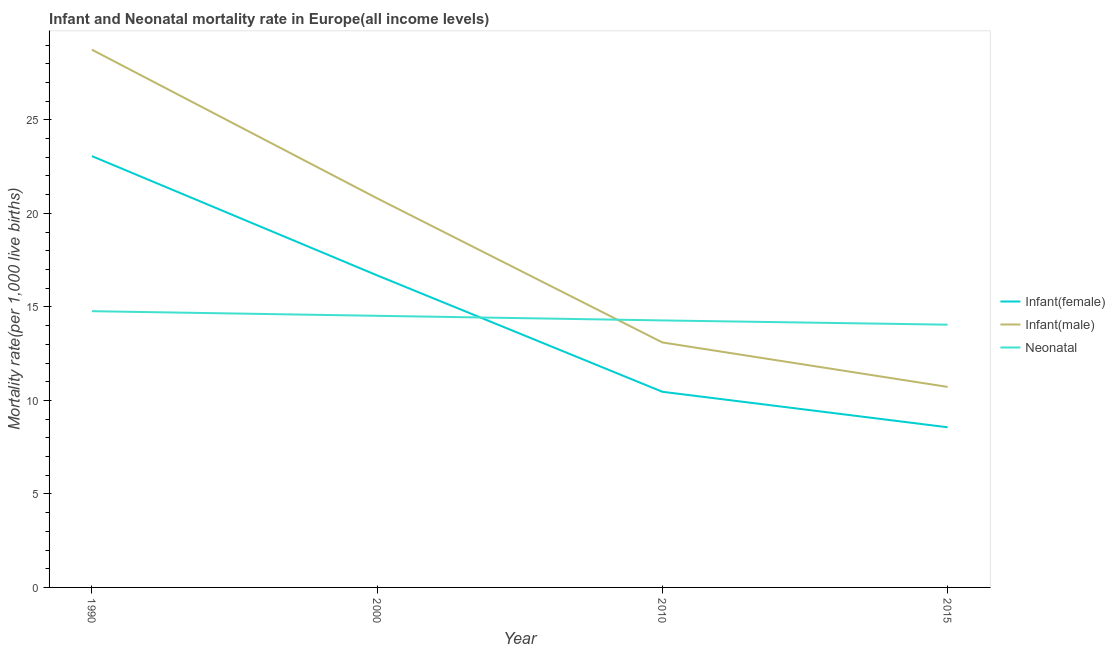How many different coloured lines are there?
Your answer should be compact. 3. Does the line corresponding to infant mortality rate(female) intersect with the line corresponding to neonatal mortality rate?
Your answer should be compact. Yes. What is the infant mortality rate(male) in 2015?
Provide a succinct answer. 10.72. Across all years, what is the maximum infant mortality rate(male)?
Your response must be concise. 28.75. Across all years, what is the minimum infant mortality rate(male)?
Your answer should be very brief. 10.72. In which year was the neonatal mortality rate minimum?
Make the answer very short. 2015. What is the total neonatal mortality rate in the graph?
Provide a succinct answer. 57.62. What is the difference between the neonatal mortality rate in 2010 and that in 2015?
Ensure brevity in your answer.  0.23. What is the difference between the infant mortality rate(male) in 2010 and the neonatal mortality rate in 2000?
Make the answer very short. -1.42. What is the average neonatal mortality rate per year?
Ensure brevity in your answer.  14.41. In the year 2015, what is the difference between the neonatal mortality rate and infant mortality rate(female)?
Provide a succinct answer. 5.49. In how many years, is the infant mortality rate(male) greater than 28?
Provide a short and direct response. 1. What is the ratio of the infant mortality rate(male) in 1990 to that in 2000?
Keep it short and to the point. 1.38. Is the infant mortality rate(female) in 1990 less than that in 2015?
Provide a succinct answer. No. Is the difference between the infant mortality rate(male) in 2010 and 2015 greater than the difference between the infant mortality rate(female) in 2010 and 2015?
Offer a very short reply. Yes. What is the difference between the highest and the second highest infant mortality rate(female)?
Offer a very short reply. 6.38. What is the difference between the highest and the lowest neonatal mortality rate?
Make the answer very short. 0.72. Is the infant mortality rate(male) strictly greater than the neonatal mortality rate over the years?
Provide a succinct answer. No. How many lines are there?
Provide a succinct answer. 3. How many years are there in the graph?
Give a very brief answer. 4. What is the difference between two consecutive major ticks on the Y-axis?
Provide a succinct answer. 5. Does the graph contain any zero values?
Provide a short and direct response. No. Where does the legend appear in the graph?
Provide a succinct answer. Center right. How many legend labels are there?
Offer a terse response. 3. How are the legend labels stacked?
Your answer should be very brief. Vertical. What is the title of the graph?
Provide a short and direct response. Infant and Neonatal mortality rate in Europe(all income levels). What is the label or title of the X-axis?
Offer a very short reply. Year. What is the label or title of the Y-axis?
Give a very brief answer. Mortality rate(per 1,0 live births). What is the Mortality rate(per 1,000 live births) in Infant(female) in 1990?
Your answer should be compact. 23.06. What is the Mortality rate(per 1,000 live births) of Infant(male) in 1990?
Your response must be concise. 28.75. What is the Mortality rate(per 1,000 live births) in Neonatal  in 1990?
Ensure brevity in your answer.  14.77. What is the Mortality rate(per 1,000 live births) in Infant(female) in 2000?
Your response must be concise. 16.69. What is the Mortality rate(per 1,000 live births) in Infant(male) in 2000?
Offer a very short reply. 20.81. What is the Mortality rate(per 1,000 live births) in Neonatal  in 2000?
Offer a terse response. 14.52. What is the Mortality rate(per 1,000 live births) of Infant(female) in 2010?
Your answer should be compact. 10.46. What is the Mortality rate(per 1,000 live births) of Infant(male) in 2010?
Provide a succinct answer. 13.1. What is the Mortality rate(per 1,000 live births) in Neonatal  in 2010?
Offer a terse response. 14.28. What is the Mortality rate(per 1,000 live births) of Infant(female) in 2015?
Make the answer very short. 8.56. What is the Mortality rate(per 1,000 live births) in Infant(male) in 2015?
Your answer should be very brief. 10.72. What is the Mortality rate(per 1,000 live births) of Neonatal  in 2015?
Your answer should be very brief. 14.05. Across all years, what is the maximum Mortality rate(per 1,000 live births) of Infant(female)?
Offer a terse response. 23.06. Across all years, what is the maximum Mortality rate(per 1,000 live births) of Infant(male)?
Offer a terse response. 28.75. Across all years, what is the maximum Mortality rate(per 1,000 live births) in Neonatal ?
Provide a short and direct response. 14.77. Across all years, what is the minimum Mortality rate(per 1,000 live births) of Infant(female)?
Offer a very short reply. 8.56. Across all years, what is the minimum Mortality rate(per 1,000 live births) in Infant(male)?
Keep it short and to the point. 10.72. Across all years, what is the minimum Mortality rate(per 1,000 live births) of Neonatal ?
Your answer should be very brief. 14.05. What is the total Mortality rate(per 1,000 live births) of Infant(female) in the graph?
Your answer should be very brief. 58.77. What is the total Mortality rate(per 1,000 live births) in Infant(male) in the graph?
Your answer should be very brief. 73.38. What is the total Mortality rate(per 1,000 live births) in Neonatal  in the graph?
Keep it short and to the point. 57.62. What is the difference between the Mortality rate(per 1,000 live births) in Infant(female) in 1990 and that in 2000?
Your answer should be very brief. 6.38. What is the difference between the Mortality rate(per 1,000 live births) in Infant(male) in 1990 and that in 2000?
Your answer should be very brief. 7.95. What is the difference between the Mortality rate(per 1,000 live births) of Neonatal  in 1990 and that in 2000?
Give a very brief answer. 0.25. What is the difference between the Mortality rate(per 1,000 live births) of Infant(female) in 1990 and that in 2010?
Offer a terse response. 12.6. What is the difference between the Mortality rate(per 1,000 live births) of Infant(male) in 1990 and that in 2010?
Keep it short and to the point. 15.65. What is the difference between the Mortality rate(per 1,000 live births) in Neonatal  in 1990 and that in 2010?
Ensure brevity in your answer.  0.49. What is the difference between the Mortality rate(per 1,000 live births) in Infant(female) in 1990 and that in 2015?
Keep it short and to the point. 14.5. What is the difference between the Mortality rate(per 1,000 live births) in Infant(male) in 1990 and that in 2015?
Your answer should be compact. 18.03. What is the difference between the Mortality rate(per 1,000 live births) in Neonatal  in 1990 and that in 2015?
Make the answer very short. 0.72. What is the difference between the Mortality rate(per 1,000 live births) in Infant(female) in 2000 and that in 2010?
Provide a succinct answer. 6.22. What is the difference between the Mortality rate(per 1,000 live births) of Infant(male) in 2000 and that in 2010?
Make the answer very short. 7.71. What is the difference between the Mortality rate(per 1,000 live births) of Neonatal  in 2000 and that in 2010?
Your answer should be very brief. 0.25. What is the difference between the Mortality rate(per 1,000 live births) of Infant(female) in 2000 and that in 2015?
Offer a very short reply. 8.12. What is the difference between the Mortality rate(per 1,000 live births) in Infant(male) in 2000 and that in 2015?
Offer a very short reply. 10.08. What is the difference between the Mortality rate(per 1,000 live births) in Neonatal  in 2000 and that in 2015?
Make the answer very short. 0.47. What is the difference between the Mortality rate(per 1,000 live births) of Infant(female) in 2010 and that in 2015?
Your answer should be compact. 1.9. What is the difference between the Mortality rate(per 1,000 live births) of Infant(male) in 2010 and that in 2015?
Your answer should be very brief. 2.38. What is the difference between the Mortality rate(per 1,000 live births) of Neonatal  in 2010 and that in 2015?
Your answer should be very brief. 0.23. What is the difference between the Mortality rate(per 1,000 live births) of Infant(female) in 1990 and the Mortality rate(per 1,000 live births) of Infant(male) in 2000?
Your response must be concise. 2.26. What is the difference between the Mortality rate(per 1,000 live births) in Infant(female) in 1990 and the Mortality rate(per 1,000 live births) in Neonatal  in 2000?
Give a very brief answer. 8.54. What is the difference between the Mortality rate(per 1,000 live births) in Infant(male) in 1990 and the Mortality rate(per 1,000 live births) in Neonatal  in 2000?
Your response must be concise. 14.23. What is the difference between the Mortality rate(per 1,000 live births) of Infant(female) in 1990 and the Mortality rate(per 1,000 live births) of Infant(male) in 2010?
Keep it short and to the point. 9.96. What is the difference between the Mortality rate(per 1,000 live births) in Infant(female) in 1990 and the Mortality rate(per 1,000 live births) in Neonatal  in 2010?
Make the answer very short. 8.79. What is the difference between the Mortality rate(per 1,000 live births) of Infant(male) in 1990 and the Mortality rate(per 1,000 live births) of Neonatal  in 2010?
Ensure brevity in your answer.  14.48. What is the difference between the Mortality rate(per 1,000 live births) of Infant(female) in 1990 and the Mortality rate(per 1,000 live births) of Infant(male) in 2015?
Your answer should be compact. 12.34. What is the difference between the Mortality rate(per 1,000 live births) in Infant(female) in 1990 and the Mortality rate(per 1,000 live births) in Neonatal  in 2015?
Provide a short and direct response. 9.01. What is the difference between the Mortality rate(per 1,000 live births) of Infant(male) in 1990 and the Mortality rate(per 1,000 live births) of Neonatal  in 2015?
Provide a short and direct response. 14.7. What is the difference between the Mortality rate(per 1,000 live births) in Infant(female) in 2000 and the Mortality rate(per 1,000 live births) in Infant(male) in 2010?
Your response must be concise. 3.59. What is the difference between the Mortality rate(per 1,000 live births) in Infant(female) in 2000 and the Mortality rate(per 1,000 live births) in Neonatal  in 2010?
Your response must be concise. 2.41. What is the difference between the Mortality rate(per 1,000 live births) in Infant(male) in 2000 and the Mortality rate(per 1,000 live births) in Neonatal  in 2010?
Offer a very short reply. 6.53. What is the difference between the Mortality rate(per 1,000 live births) in Infant(female) in 2000 and the Mortality rate(per 1,000 live births) in Infant(male) in 2015?
Provide a succinct answer. 5.96. What is the difference between the Mortality rate(per 1,000 live births) of Infant(female) in 2000 and the Mortality rate(per 1,000 live births) of Neonatal  in 2015?
Provide a short and direct response. 2.64. What is the difference between the Mortality rate(per 1,000 live births) of Infant(male) in 2000 and the Mortality rate(per 1,000 live births) of Neonatal  in 2015?
Offer a very short reply. 6.76. What is the difference between the Mortality rate(per 1,000 live births) in Infant(female) in 2010 and the Mortality rate(per 1,000 live births) in Infant(male) in 2015?
Provide a short and direct response. -0.26. What is the difference between the Mortality rate(per 1,000 live births) in Infant(female) in 2010 and the Mortality rate(per 1,000 live births) in Neonatal  in 2015?
Your answer should be compact. -3.59. What is the difference between the Mortality rate(per 1,000 live births) of Infant(male) in 2010 and the Mortality rate(per 1,000 live births) of Neonatal  in 2015?
Give a very brief answer. -0.95. What is the average Mortality rate(per 1,000 live births) of Infant(female) per year?
Keep it short and to the point. 14.69. What is the average Mortality rate(per 1,000 live births) in Infant(male) per year?
Your response must be concise. 18.35. What is the average Mortality rate(per 1,000 live births) in Neonatal  per year?
Provide a succinct answer. 14.41. In the year 1990, what is the difference between the Mortality rate(per 1,000 live births) of Infant(female) and Mortality rate(per 1,000 live births) of Infant(male)?
Make the answer very short. -5.69. In the year 1990, what is the difference between the Mortality rate(per 1,000 live births) of Infant(female) and Mortality rate(per 1,000 live births) of Neonatal ?
Your response must be concise. 8.29. In the year 1990, what is the difference between the Mortality rate(per 1,000 live births) in Infant(male) and Mortality rate(per 1,000 live births) in Neonatal ?
Your answer should be very brief. 13.98. In the year 2000, what is the difference between the Mortality rate(per 1,000 live births) in Infant(female) and Mortality rate(per 1,000 live births) in Infant(male)?
Your response must be concise. -4.12. In the year 2000, what is the difference between the Mortality rate(per 1,000 live births) of Infant(female) and Mortality rate(per 1,000 live births) of Neonatal ?
Provide a succinct answer. 2.16. In the year 2000, what is the difference between the Mortality rate(per 1,000 live births) of Infant(male) and Mortality rate(per 1,000 live births) of Neonatal ?
Offer a very short reply. 6.28. In the year 2010, what is the difference between the Mortality rate(per 1,000 live births) in Infant(female) and Mortality rate(per 1,000 live births) in Infant(male)?
Your answer should be very brief. -2.64. In the year 2010, what is the difference between the Mortality rate(per 1,000 live births) of Infant(female) and Mortality rate(per 1,000 live births) of Neonatal ?
Keep it short and to the point. -3.82. In the year 2010, what is the difference between the Mortality rate(per 1,000 live births) of Infant(male) and Mortality rate(per 1,000 live births) of Neonatal ?
Provide a short and direct response. -1.18. In the year 2015, what is the difference between the Mortality rate(per 1,000 live births) in Infant(female) and Mortality rate(per 1,000 live births) in Infant(male)?
Keep it short and to the point. -2.16. In the year 2015, what is the difference between the Mortality rate(per 1,000 live births) in Infant(female) and Mortality rate(per 1,000 live births) in Neonatal ?
Provide a succinct answer. -5.49. In the year 2015, what is the difference between the Mortality rate(per 1,000 live births) in Infant(male) and Mortality rate(per 1,000 live births) in Neonatal ?
Your response must be concise. -3.33. What is the ratio of the Mortality rate(per 1,000 live births) of Infant(female) in 1990 to that in 2000?
Your response must be concise. 1.38. What is the ratio of the Mortality rate(per 1,000 live births) in Infant(male) in 1990 to that in 2000?
Offer a terse response. 1.38. What is the ratio of the Mortality rate(per 1,000 live births) in Neonatal  in 1990 to that in 2000?
Give a very brief answer. 1.02. What is the ratio of the Mortality rate(per 1,000 live births) in Infant(female) in 1990 to that in 2010?
Ensure brevity in your answer.  2.2. What is the ratio of the Mortality rate(per 1,000 live births) in Infant(male) in 1990 to that in 2010?
Give a very brief answer. 2.19. What is the ratio of the Mortality rate(per 1,000 live births) in Neonatal  in 1990 to that in 2010?
Offer a terse response. 1.03. What is the ratio of the Mortality rate(per 1,000 live births) in Infant(female) in 1990 to that in 2015?
Your answer should be compact. 2.69. What is the ratio of the Mortality rate(per 1,000 live births) in Infant(male) in 1990 to that in 2015?
Your response must be concise. 2.68. What is the ratio of the Mortality rate(per 1,000 live births) in Neonatal  in 1990 to that in 2015?
Your answer should be very brief. 1.05. What is the ratio of the Mortality rate(per 1,000 live births) in Infant(female) in 2000 to that in 2010?
Provide a short and direct response. 1.59. What is the ratio of the Mortality rate(per 1,000 live births) of Infant(male) in 2000 to that in 2010?
Offer a very short reply. 1.59. What is the ratio of the Mortality rate(per 1,000 live births) of Neonatal  in 2000 to that in 2010?
Provide a succinct answer. 1.02. What is the ratio of the Mortality rate(per 1,000 live births) of Infant(female) in 2000 to that in 2015?
Make the answer very short. 1.95. What is the ratio of the Mortality rate(per 1,000 live births) of Infant(male) in 2000 to that in 2015?
Provide a short and direct response. 1.94. What is the ratio of the Mortality rate(per 1,000 live births) of Neonatal  in 2000 to that in 2015?
Keep it short and to the point. 1.03. What is the ratio of the Mortality rate(per 1,000 live births) of Infant(female) in 2010 to that in 2015?
Your answer should be very brief. 1.22. What is the ratio of the Mortality rate(per 1,000 live births) in Infant(male) in 2010 to that in 2015?
Provide a short and direct response. 1.22. What is the ratio of the Mortality rate(per 1,000 live births) of Neonatal  in 2010 to that in 2015?
Your answer should be very brief. 1.02. What is the difference between the highest and the second highest Mortality rate(per 1,000 live births) of Infant(female)?
Give a very brief answer. 6.38. What is the difference between the highest and the second highest Mortality rate(per 1,000 live births) in Infant(male)?
Your answer should be very brief. 7.95. What is the difference between the highest and the second highest Mortality rate(per 1,000 live births) of Neonatal ?
Offer a very short reply. 0.25. What is the difference between the highest and the lowest Mortality rate(per 1,000 live births) in Infant(female)?
Your answer should be very brief. 14.5. What is the difference between the highest and the lowest Mortality rate(per 1,000 live births) in Infant(male)?
Make the answer very short. 18.03. What is the difference between the highest and the lowest Mortality rate(per 1,000 live births) of Neonatal ?
Your answer should be very brief. 0.72. 